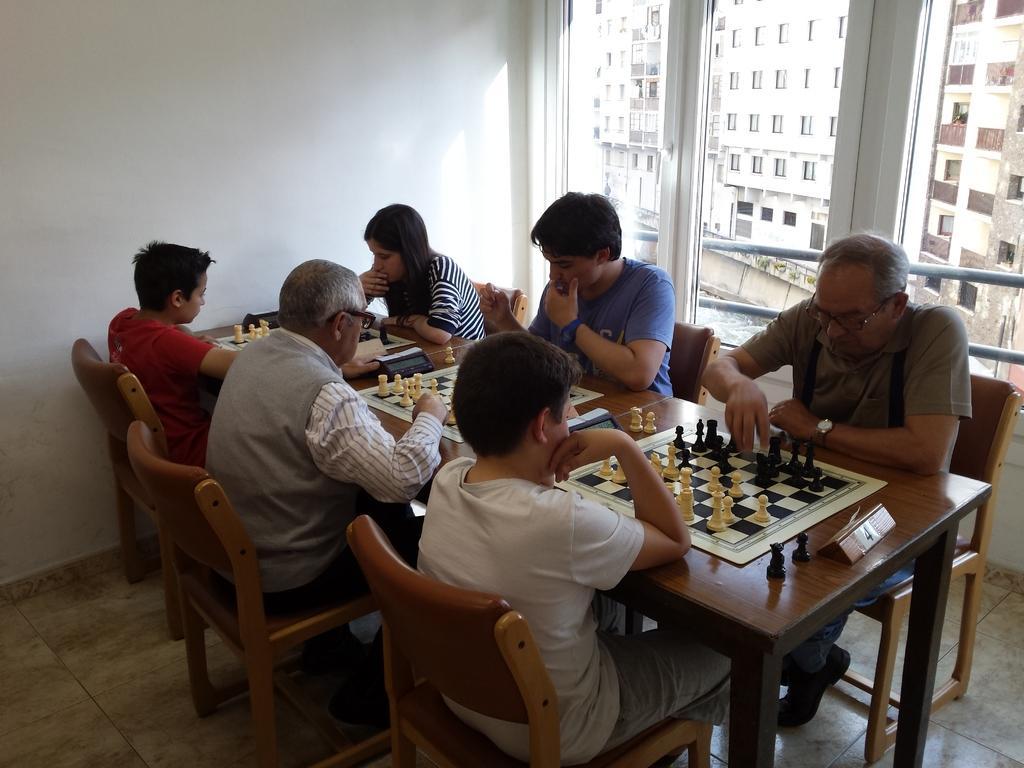Could you give a brief overview of what you see in this image? This picture is clicked inside a room. We see six people sitting on chair and they are playing chess. Among the six people, we see a woman, three men and two boys playing chess. On background, we see many buildings and to the left of them, to the right of them, we see a wall which is white in color. 